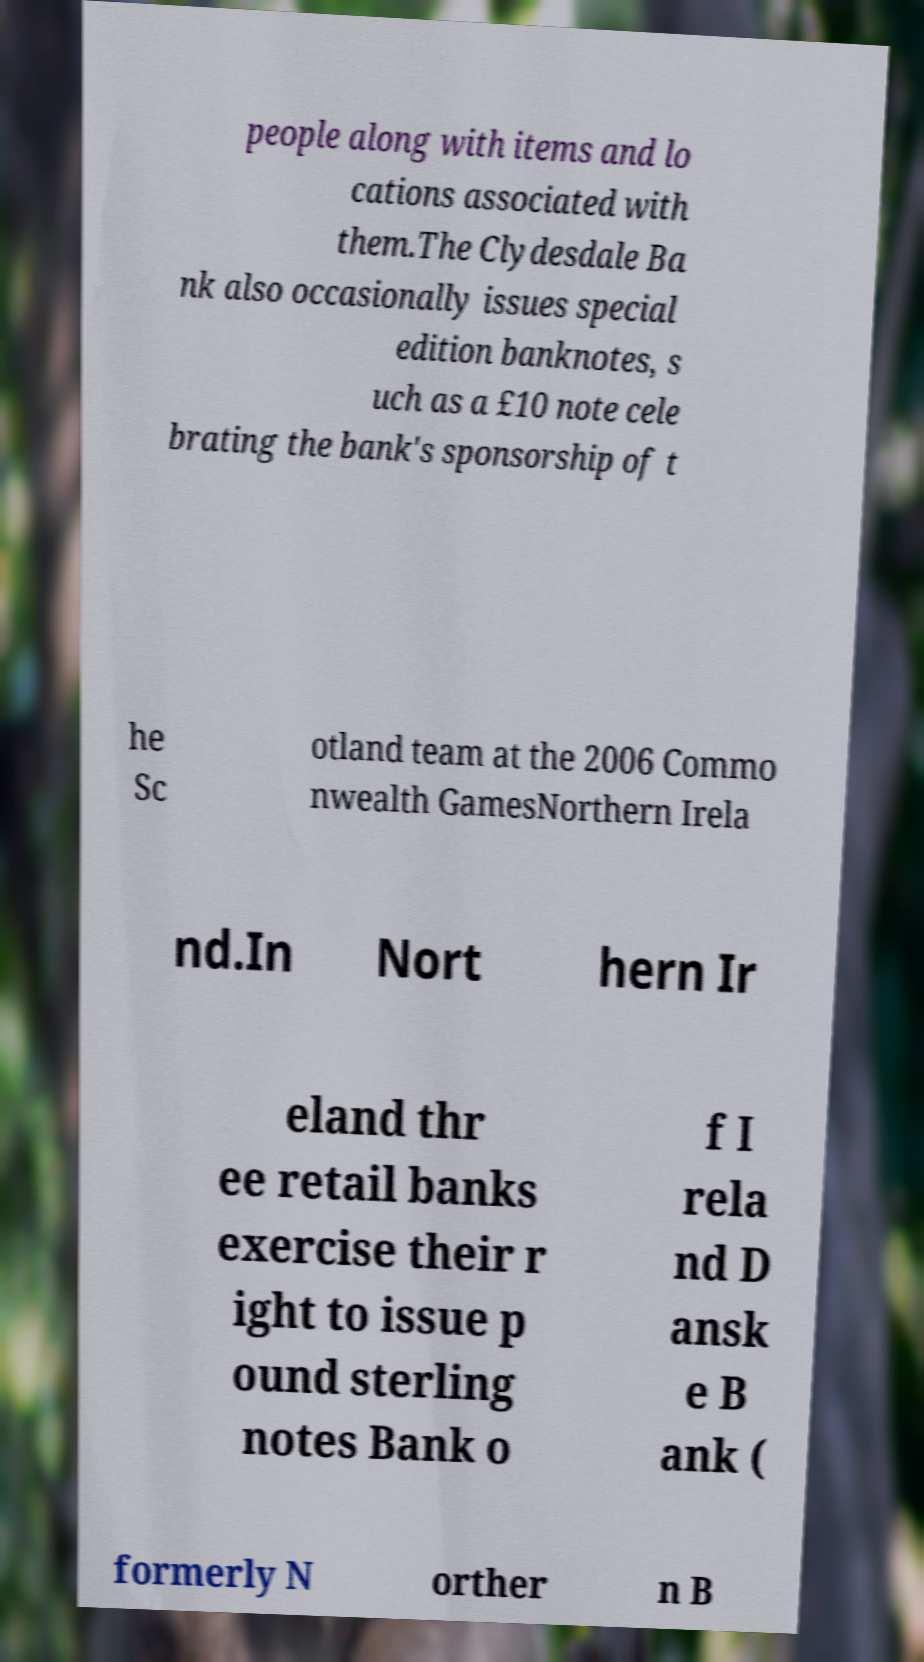Please identify and transcribe the text found in this image. people along with items and lo cations associated with them.The Clydesdale Ba nk also occasionally issues special edition banknotes, s uch as a £10 note cele brating the bank's sponsorship of t he Sc otland team at the 2006 Commo nwealth GamesNorthern Irela nd.In Nort hern Ir eland thr ee retail banks exercise their r ight to issue p ound sterling notes Bank o f I rela nd D ansk e B ank ( formerly N orther n B 